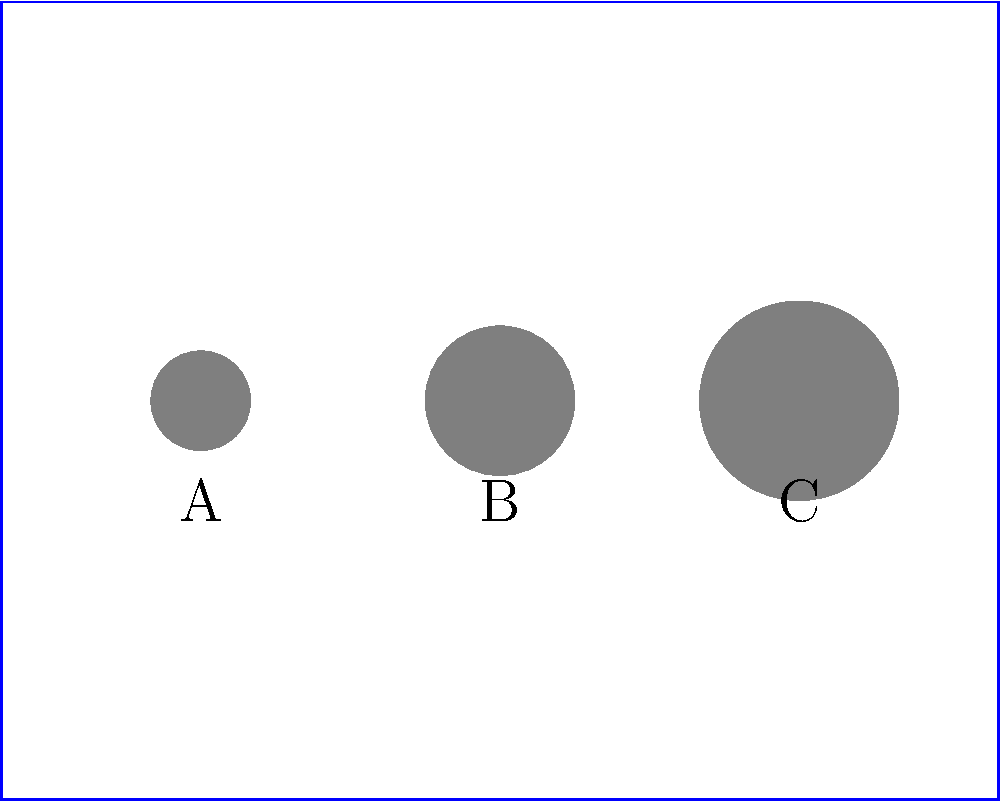In the depicted medieval fresco, three figures (A, B, and C) are shown. If figure B represents a person of average height (170 cm), estimate the height of figure C in centimeters. To estimate the height of figure C, we need to follow these steps:

1. Observe that the figures increase in size from left to right (A to C).
2. Figure B is given as the reference, representing an average height of 170 cm.
3. Compare the relative sizes of figures B and C:
   - Figure B's diameter is approximately 0.75 units
   - Figure C's diameter is approximately 1 unit
4. Calculate the ratio of their sizes: $\frac{1}{0.75} = \frac{4}{3}$
5. Since the height is proportional to the diameter, we can assume that figure C is $\frac{4}{3}$ times taller than figure B.
6. Calculate the height of figure C:
   $170 \text{ cm} \times \frac{4}{3} = 226.67 \text{ cm}$

Rounding to the nearest centimeter, the estimated height of figure C is 227 cm.
Answer: 227 cm 